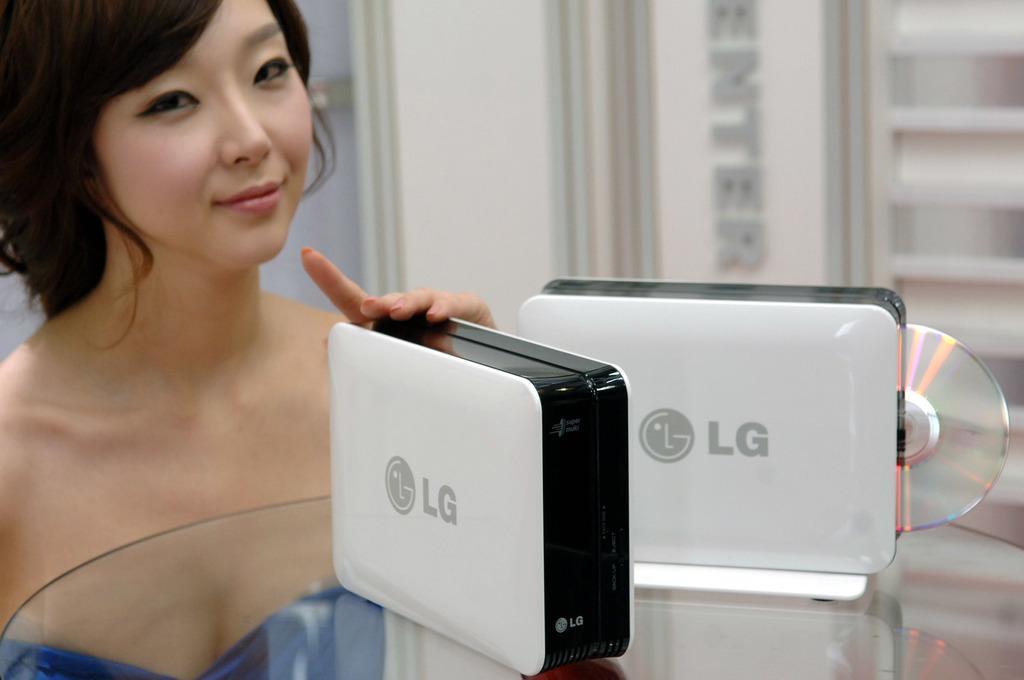Please provide a concise description of this image. On the left side, there is a woman smiling and placing her fingers of a hand on a device which is placed on a table on which there is another device and a CD. In the background, there is a wall. And the background is blurred. 